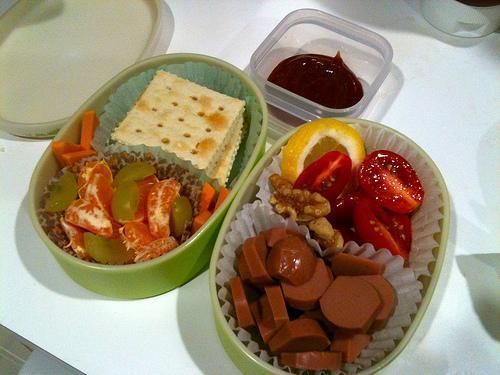How many green containers are there?
Give a very brief answer. 2. 